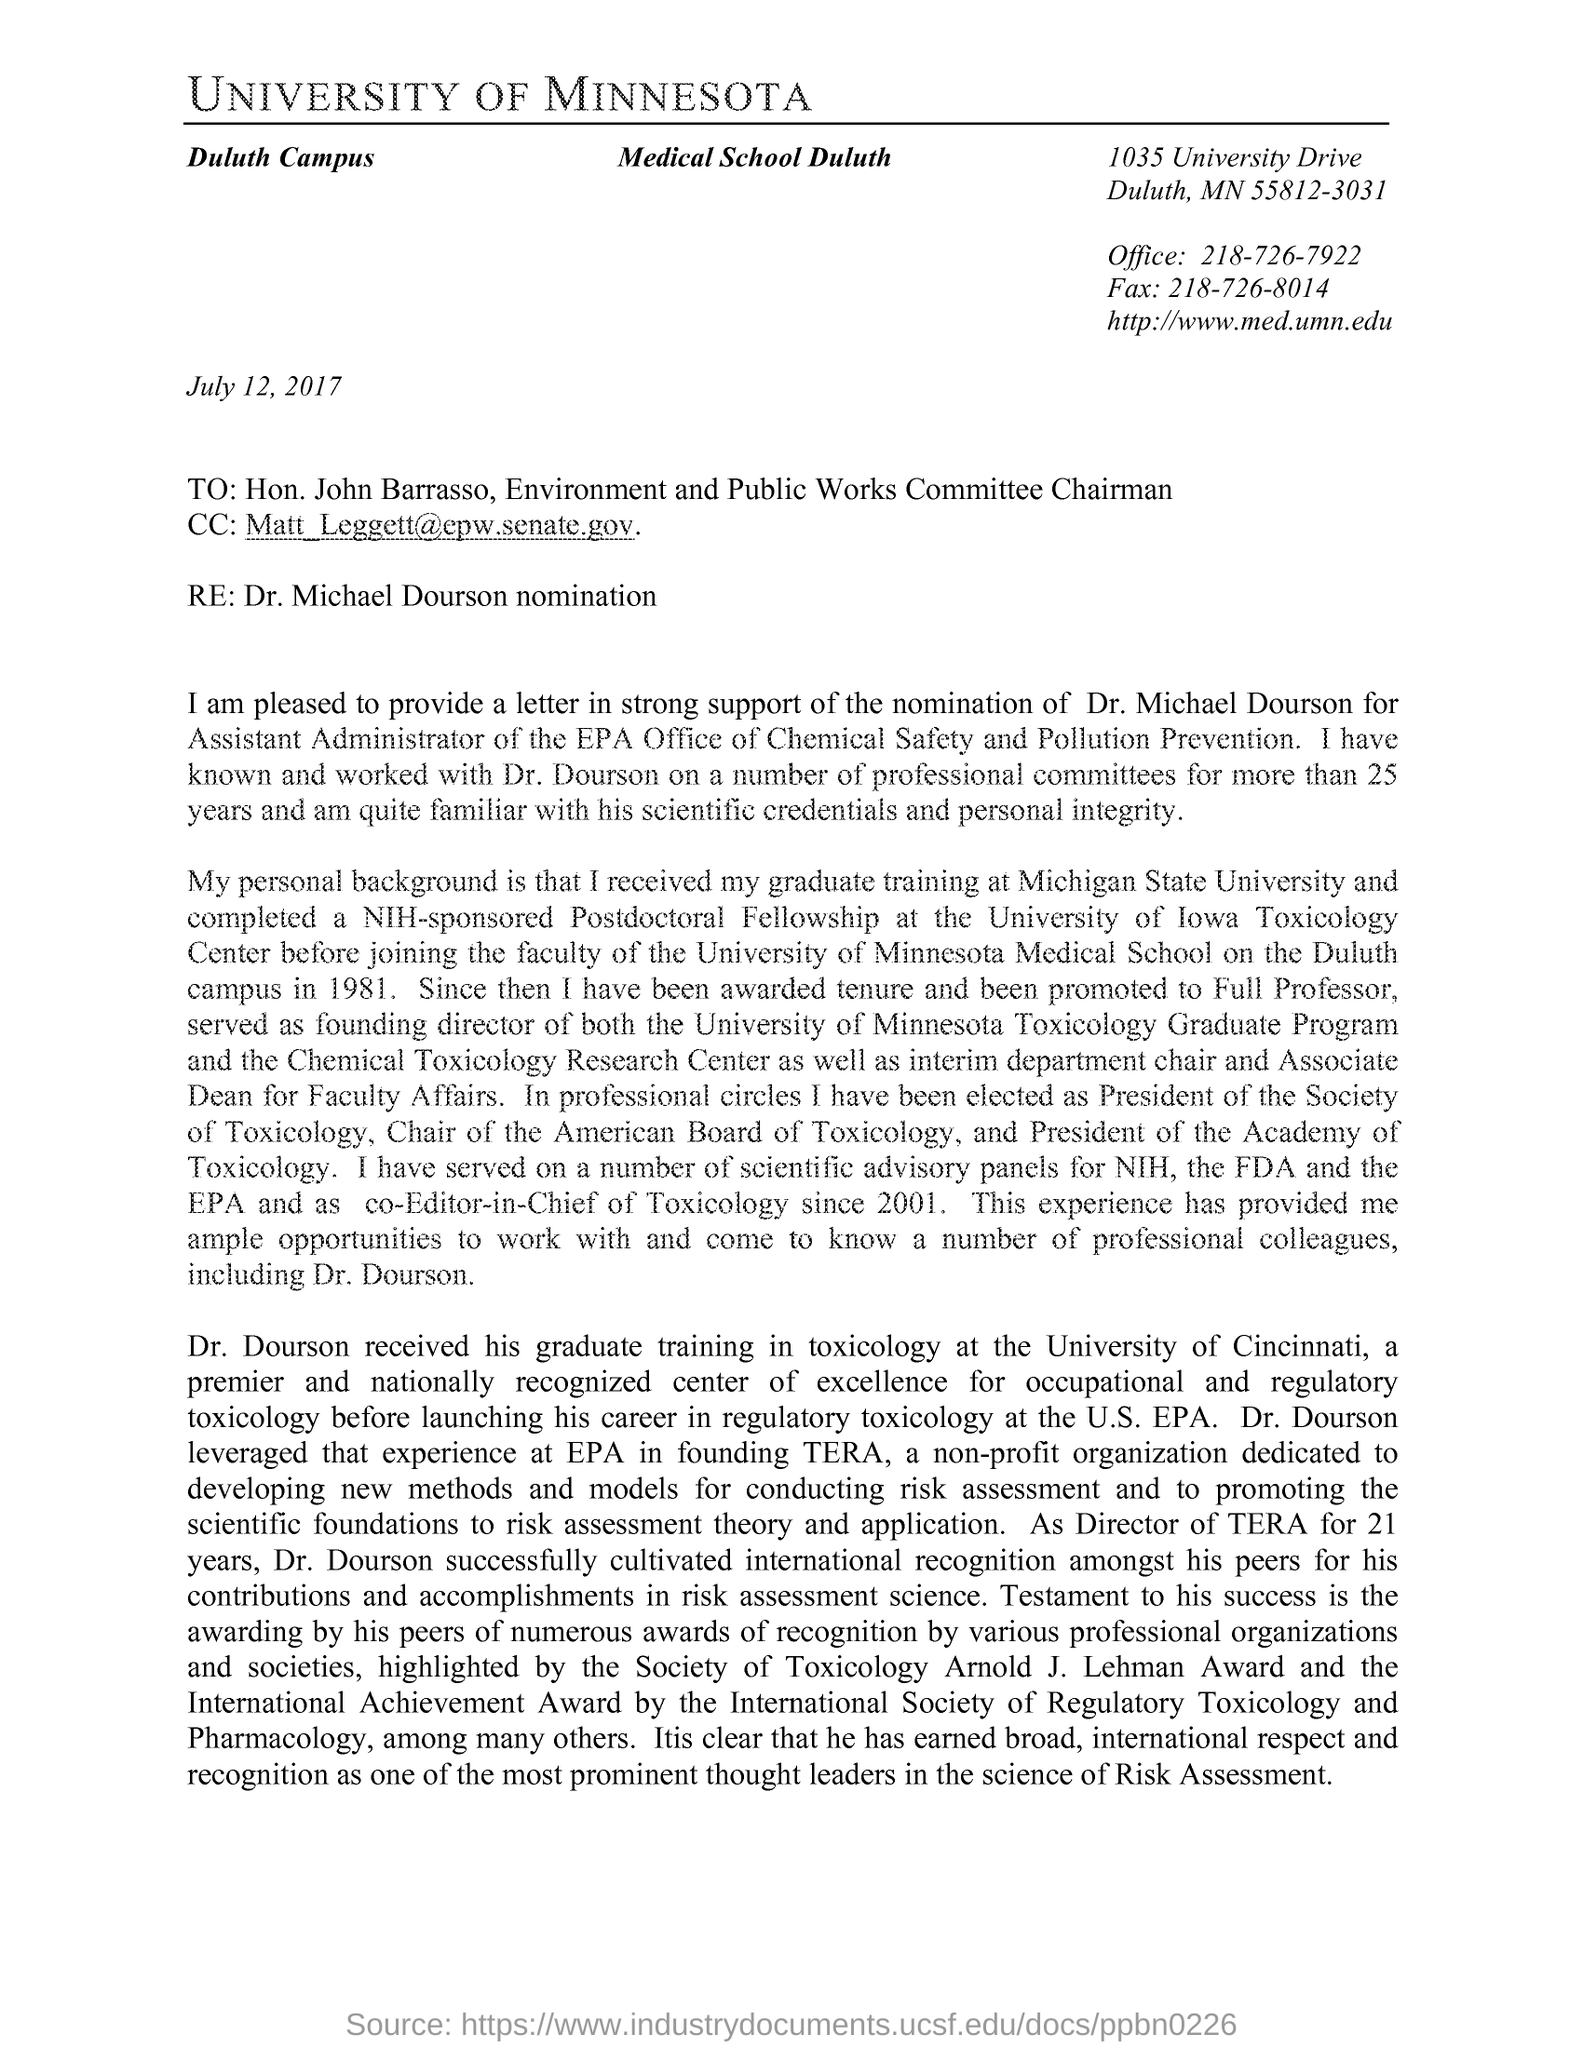Draw attention to some important aspects in this diagram. The fax number is 218-726-8014. The document indicates that the date mentioned is July 12, 2017. The office phone number is 218-726-7922. The chairman of the Environment and Public Works Committee is John Barrasso. 